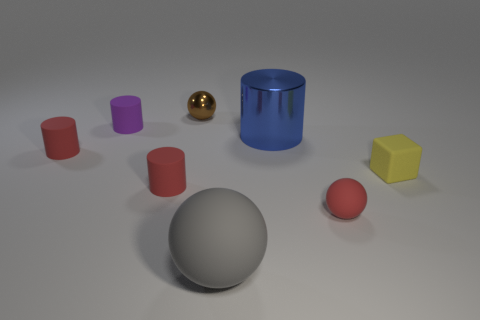Subtract all small balls. How many balls are left? 1 Subtract all brown blocks. How many red cylinders are left? 2 Subtract all blue cylinders. How many cylinders are left? 3 Subtract 1 cylinders. How many cylinders are left? 3 Add 2 purple matte things. How many objects exist? 10 Subtract all cubes. How many objects are left? 7 Subtract all yellow balls. Subtract all brown blocks. How many balls are left? 3 Subtract all matte balls. Subtract all small yellow spheres. How many objects are left? 6 Add 2 large blue cylinders. How many large blue cylinders are left? 3 Add 1 large gray matte blocks. How many large gray matte blocks exist? 1 